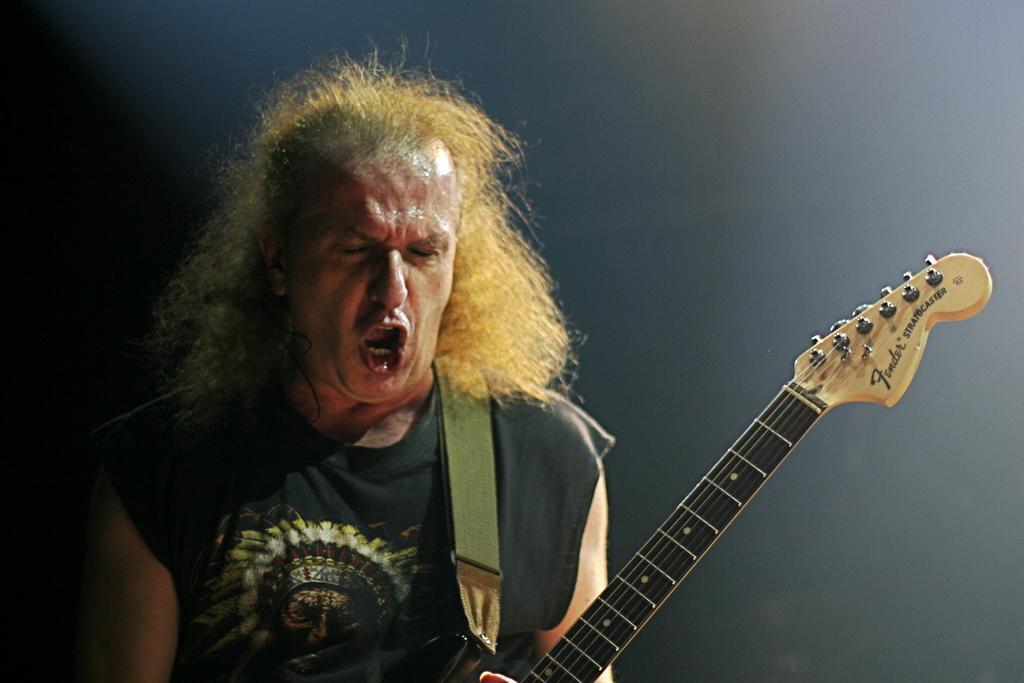Please provide a concise description of this image. As we can see in a picture that a man is holding a guitar is singing. 